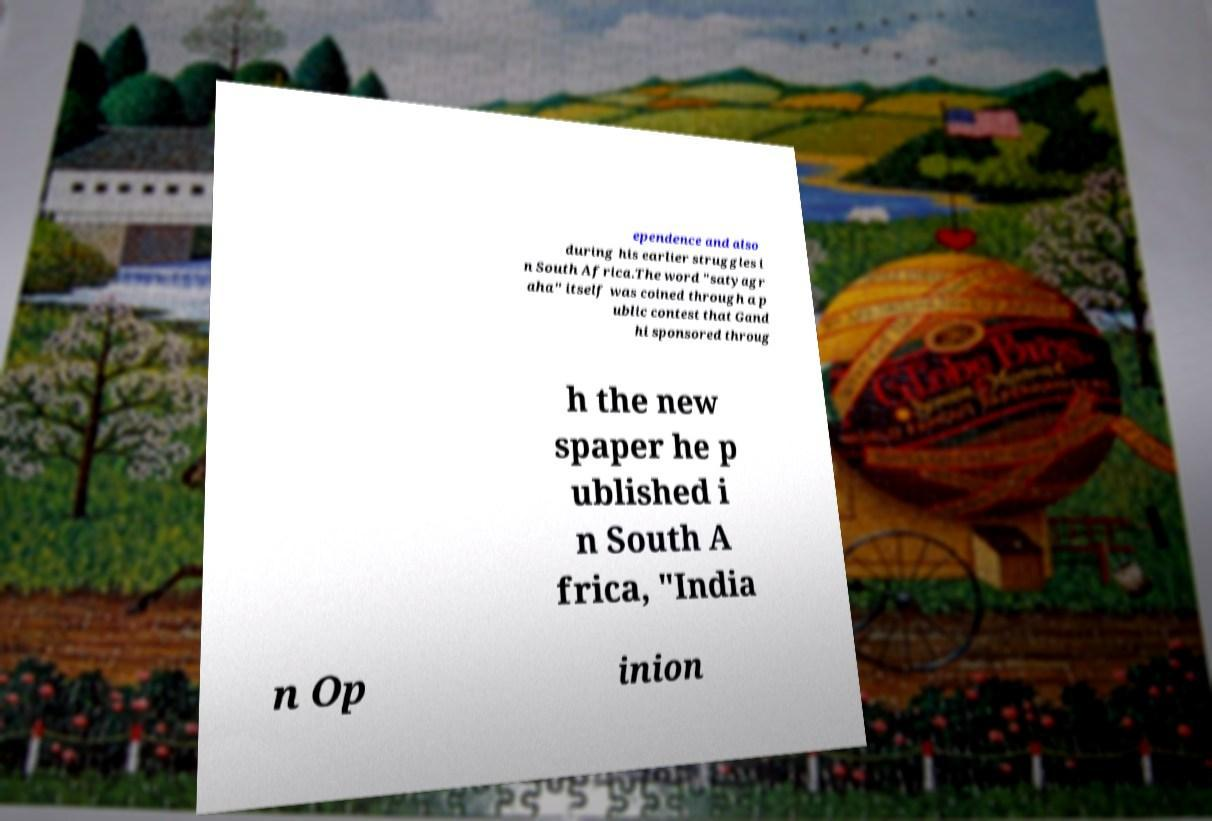Could you assist in decoding the text presented in this image and type it out clearly? ependence and also during his earlier struggles i n South Africa.The word "satyagr aha" itself was coined through a p ublic contest that Gand hi sponsored throug h the new spaper he p ublished i n South A frica, "India n Op inion 